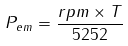<formula> <loc_0><loc_0><loc_500><loc_500>P _ { e m } = \frac { r p m \times T } { 5 2 5 2 }</formula> 